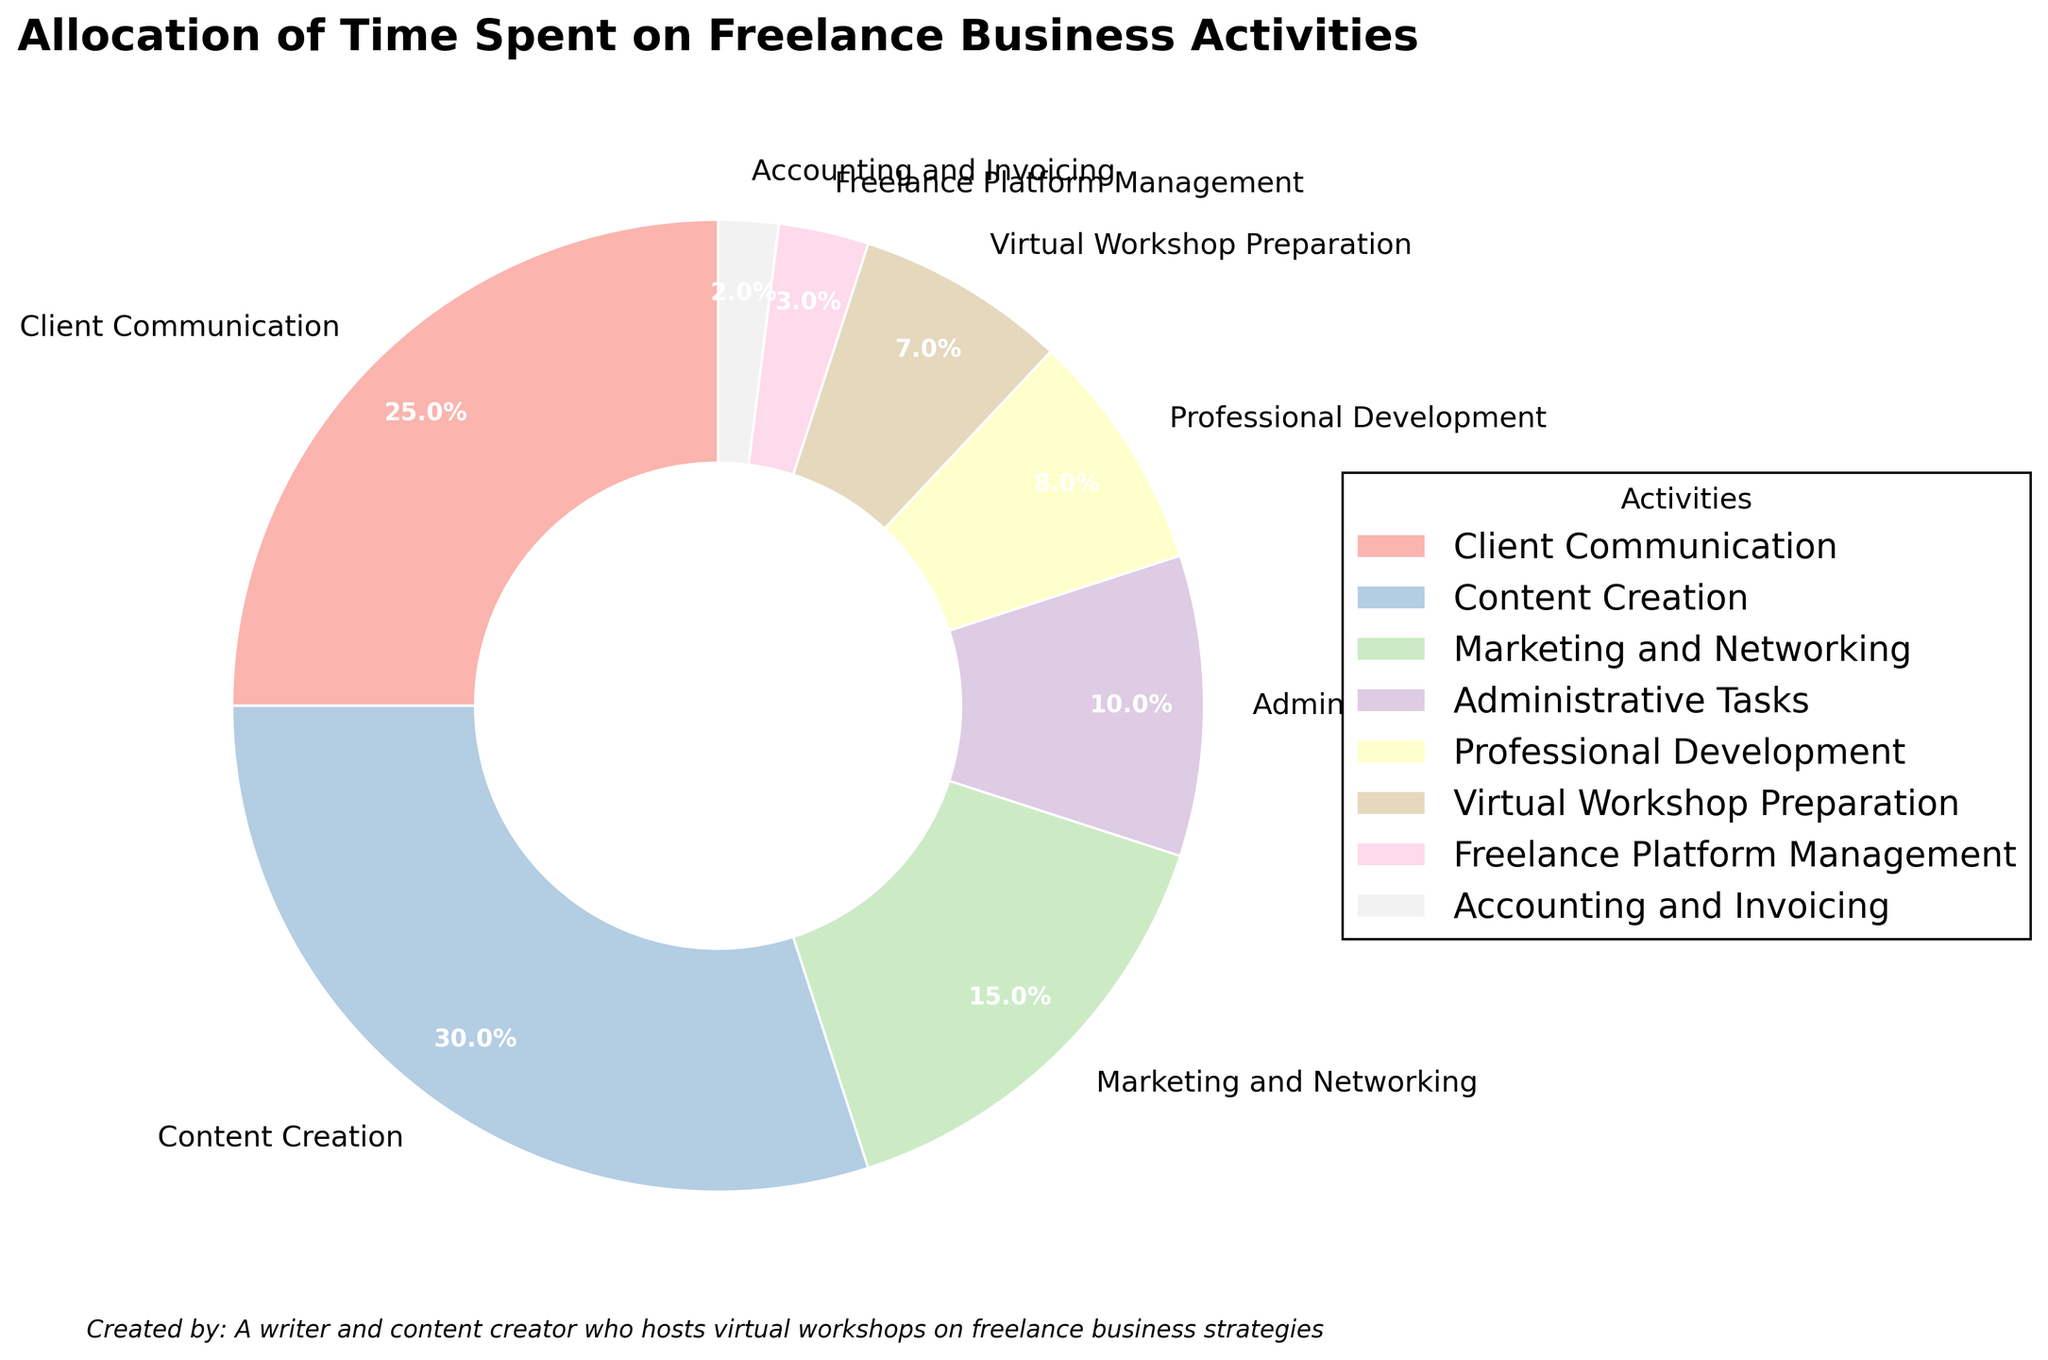What's the percentage of time spent on Marketing and Networking combined with Professional Development? The percentage of time spent on Marketing and Networking is 15%, and for Professional Development, it is 8%. Adding these percentages together gives us 15% + 8% = 23%.
Answer: 23% Which activity takes up the highest percentage of time? By looking at the labeled percentages in the pie chart, Content Creation stands out as the activity with the highest percentage, which is 30%.
Answer: Content Creation How much more time is spent on Administrative Tasks compared to Accounting and Invoicing? The percentage of time spent on Administrative Tasks is 10%, and for Accounting and Invoicing, it is 2%. The difference is 10% - 2% = 8%.
Answer: 8% What is the total percentage of time spent on Virtual Workshop Preparation and Freelance Platform Management? The percentage of time spent on Virtual Workshop Preparation is 7%, and on Freelance Platform Management, it is 3%. Adding these together gives 7% + 3% = 10%.
Answer: 10% Which activities combined contribute to 40% of the total time spent? Adding the percentages of different activities, we get: 
25% (Client Communication) + 15% (Marketing and Networking) = 40% 
So, Client Communication and Marketing and Networking together make up 40%.
Answer: Client Communication and Marketing and Networking What fraction of the time is dedicated to Client Communication relative to the total time for Content Creation and Administrative Tasks? Client Communication takes up 25%, and Content Creation and Administrative Tasks together take up 30% + 10% = 40%. The fraction is 25% / 40% = 0.625.
Answer: 0.625 Which activity has the smallest allocation of time? From the labelled percentages, Accounting and Invoicing has the smallest allocation of time, accounting for 2%.
Answer: Accounting and Invoicing If time allocated to Content Creation is decreased by 5% and added to Virtual Workshop Preparation, what would be the new percentage for both activities? Initially, Content Creation is 30%, and Virtual Workshop Preparation is 7%. Decreasing Content Creation by 5% results in 30% - 5% = 25%, and increasing Virtual Workshop Preparation by the same 5% gives 7% + 5% = 12%.
Answer: Content Creation: 25%; Virtual Workshop Preparation: 12% 